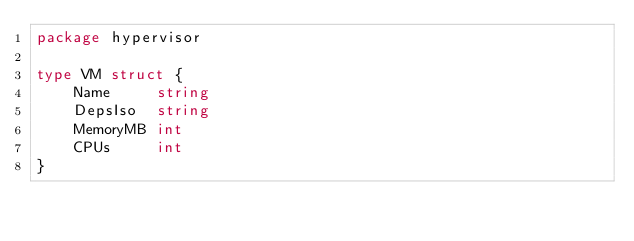Convert code to text. <code><loc_0><loc_0><loc_500><loc_500><_Go_>package hypervisor

type VM struct {
	Name     string
	DepsIso  string
	MemoryMB int
	CPUs     int
}
</code> 